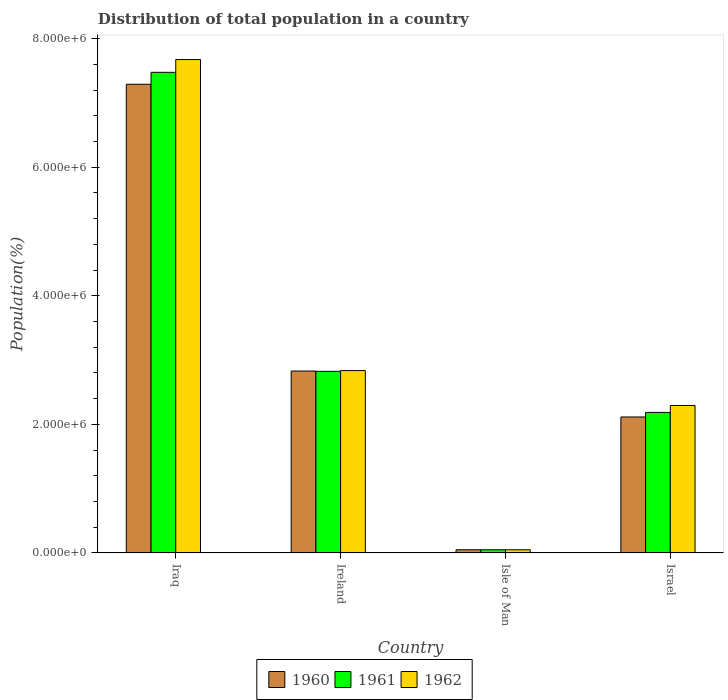How many different coloured bars are there?
Offer a very short reply. 3. How many groups of bars are there?
Make the answer very short. 4. What is the label of the 3rd group of bars from the left?
Make the answer very short. Isle of Man. What is the population of in 1961 in Isle of Man?
Provide a short and direct response. 4.84e+04. Across all countries, what is the maximum population of in 1962?
Make the answer very short. 7.67e+06. Across all countries, what is the minimum population of in 1961?
Provide a short and direct response. 4.84e+04. In which country was the population of in 1962 maximum?
Your answer should be compact. Iraq. In which country was the population of in 1962 minimum?
Your answer should be very brief. Isle of Man. What is the total population of in 1960 in the graph?
Offer a very short reply. 1.23e+07. What is the difference between the population of in 1960 in Ireland and that in Isle of Man?
Your answer should be very brief. 2.78e+06. What is the difference between the population of in 1962 in Isle of Man and the population of in 1960 in Ireland?
Your answer should be compact. -2.78e+06. What is the average population of in 1960 per country?
Make the answer very short. 3.07e+06. What is the difference between the population of of/in 1962 and population of of/in 1960 in Israel?
Your answer should be very brief. 1.79e+05. What is the ratio of the population of in 1962 in Isle of Man to that in Israel?
Your answer should be very brief. 0.02. What is the difference between the highest and the second highest population of in 1962?
Your answer should be compact. -5.43e+05. What is the difference between the highest and the lowest population of in 1961?
Ensure brevity in your answer.  7.43e+06. In how many countries, is the population of in 1960 greater than the average population of in 1960 taken over all countries?
Give a very brief answer. 1. Is the sum of the population of in 1960 in Iraq and Israel greater than the maximum population of in 1961 across all countries?
Your answer should be compact. Yes. What does the 3rd bar from the left in Israel represents?
Your response must be concise. 1962. Are all the bars in the graph horizontal?
Provide a succinct answer. No. How many countries are there in the graph?
Your response must be concise. 4. Are the values on the major ticks of Y-axis written in scientific E-notation?
Ensure brevity in your answer.  Yes. Where does the legend appear in the graph?
Make the answer very short. Bottom center. How are the legend labels stacked?
Ensure brevity in your answer.  Horizontal. What is the title of the graph?
Ensure brevity in your answer.  Distribution of total population in a country. Does "2004" appear as one of the legend labels in the graph?
Provide a succinct answer. No. What is the label or title of the X-axis?
Offer a terse response. Country. What is the label or title of the Y-axis?
Ensure brevity in your answer.  Population(%). What is the Population(%) in 1960 in Iraq?
Your response must be concise. 7.29e+06. What is the Population(%) of 1961 in Iraq?
Give a very brief answer. 7.48e+06. What is the Population(%) of 1962 in Iraq?
Your answer should be compact. 7.67e+06. What is the Population(%) of 1960 in Ireland?
Give a very brief answer. 2.83e+06. What is the Population(%) in 1961 in Ireland?
Give a very brief answer. 2.82e+06. What is the Population(%) in 1962 in Ireland?
Make the answer very short. 2.84e+06. What is the Population(%) of 1960 in Isle of Man?
Your response must be concise. 4.84e+04. What is the Population(%) in 1961 in Isle of Man?
Your answer should be compact. 4.84e+04. What is the Population(%) of 1962 in Isle of Man?
Provide a short and direct response. 4.86e+04. What is the Population(%) of 1960 in Israel?
Your response must be concise. 2.11e+06. What is the Population(%) in 1961 in Israel?
Offer a very short reply. 2.18e+06. What is the Population(%) in 1962 in Israel?
Provide a succinct answer. 2.29e+06. Across all countries, what is the maximum Population(%) of 1960?
Your answer should be very brief. 7.29e+06. Across all countries, what is the maximum Population(%) of 1961?
Offer a very short reply. 7.48e+06. Across all countries, what is the maximum Population(%) in 1962?
Your response must be concise. 7.67e+06. Across all countries, what is the minimum Population(%) in 1960?
Provide a succinct answer. 4.84e+04. Across all countries, what is the minimum Population(%) in 1961?
Your answer should be compact. 4.84e+04. Across all countries, what is the minimum Population(%) in 1962?
Make the answer very short. 4.86e+04. What is the total Population(%) in 1960 in the graph?
Offer a very short reply. 1.23e+07. What is the total Population(%) of 1961 in the graph?
Your response must be concise. 1.25e+07. What is the total Population(%) in 1962 in the graph?
Offer a terse response. 1.29e+07. What is the difference between the Population(%) in 1960 in Iraq and that in Ireland?
Make the answer very short. 4.46e+06. What is the difference between the Population(%) in 1961 in Iraq and that in Ireland?
Your answer should be very brief. 4.65e+06. What is the difference between the Population(%) in 1962 in Iraq and that in Ireland?
Ensure brevity in your answer.  4.84e+06. What is the difference between the Population(%) in 1960 in Iraq and that in Isle of Man?
Your response must be concise. 7.24e+06. What is the difference between the Population(%) of 1961 in Iraq and that in Isle of Man?
Your answer should be compact. 7.43e+06. What is the difference between the Population(%) of 1962 in Iraq and that in Isle of Man?
Offer a terse response. 7.63e+06. What is the difference between the Population(%) in 1960 in Iraq and that in Israel?
Your answer should be compact. 5.18e+06. What is the difference between the Population(%) of 1961 in Iraq and that in Israel?
Your response must be concise. 5.29e+06. What is the difference between the Population(%) of 1962 in Iraq and that in Israel?
Keep it short and to the point. 5.38e+06. What is the difference between the Population(%) of 1960 in Ireland and that in Isle of Man?
Ensure brevity in your answer.  2.78e+06. What is the difference between the Population(%) in 1961 in Ireland and that in Isle of Man?
Your response must be concise. 2.78e+06. What is the difference between the Population(%) in 1962 in Ireland and that in Isle of Man?
Provide a succinct answer. 2.79e+06. What is the difference between the Population(%) of 1960 in Ireland and that in Israel?
Offer a very short reply. 7.15e+05. What is the difference between the Population(%) of 1961 in Ireland and that in Israel?
Ensure brevity in your answer.  6.39e+05. What is the difference between the Population(%) of 1962 in Ireland and that in Israel?
Make the answer very short. 5.43e+05. What is the difference between the Population(%) in 1960 in Isle of Man and that in Israel?
Your answer should be very brief. -2.07e+06. What is the difference between the Population(%) in 1961 in Isle of Man and that in Israel?
Your response must be concise. -2.14e+06. What is the difference between the Population(%) in 1962 in Isle of Man and that in Israel?
Provide a succinct answer. -2.24e+06. What is the difference between the Population(%) of 1960 in Iraq and the Population(%) of 1961 in Ireland?
Provide a short and direct response. 4.47e+06. What is the difference between the Population(%) of 1960 in Iraq and the Population(%) of 1962 in Ireland?
Make the answer very short. 4.45e+06. What is the difference between the Population(%) of 1961 in Iraq and the Population(%) of 1962 in Ireland?
Keep it short and to the point. 4.64e+06. What is the difference between the Population(%) in 1960 in Iraq and the Population(%) in 1961 in Isle of Man?
Provide a short and direct response. 7.24e+06. What is the difference between the Population(%) of 1960 in Iraq and the Population(%) of 1962 in Isle of Man?
Keep it short and to the point. 7.24e+06. What is the difference between the Population(%) in 1961 in Iraq and the Population(%) in 1962 in Isle of Man?
Provide a short and direct response. 7.43e+06. What is the difference between the Population(%) in 1960 in Iraq and the Population(%) in 1961 in Israel?
Your answer should be compact. 5.10e+06. What is the difference between the Population(%) of 1960 in Iraq and the Population(%) of 1962 in Israel?
Your answer should be very brief. 5.00e+06. What is the difference between the Population(%) in 1961 in Iraq and the Population(%) in 1962 in Israel?
Keep it short and to the point. 5.18e+06. What is the difference between the Population(%) of 1960 in Ireland and the Population(%) of 1961 in Isle of Man?
Keep it short and to the point. 2.78e+06. What is the difference between the Population(%) of 1960 in Ireland and the Population(%) of 1962 in Isle of Man?
Offer a terse response. 2.78e+06. What is the difference between the Population(%) in 1961 in Ireland and the Population(%) in 1962 in Isle of Man?
Your answer should be compact. 2.78e+06. What is the difference between the Population(%) of 1960 in Ireland and the Population(%) of 1961 in Israel?
Offer a terse response. 6.44e+05. What is the difference between the Population(%) of 1960 in Ireland and the Population(%) of 1962 in Israel?
Your response must be concise. 5.36e+05. What is the difference between the Population(%) in 1961 in Ireland and the Population(%) in 1962 in Israel?
Offer a very short reply. 5.31e+05. What is the difference between the Population(%) in 1960 in Isle of Man and the Population(%) in 1961 in Israel?
Give a very brief answer. -2.14e+06. What is the difference between the Population(%) of 1960 in Isle of Man and the Population(%) of 1962 in Israel?
Ensure brevity in your answer.  -2.24e+06. What is the difference between the Population(%) of 1961 in Isle of Man and the Population(%) of 1962 in Israel?
Give a very brief answer. -2.24e+06. What is the average Population(%) in 1960 per country?
Ensure brevity in your answer.  3.07e+06. What is the average Population(%) of 1961 per country?
Your answer should be compact. 3.13e+06. What is the average Population(%) of 1962 per country?
Your answer should be very brief. 3.21e+06. What is the difference between the Population(%) of 1960 and Population(%) of 1961 in Iraq?
Give a very brief answer. -1.86e+05. What is the difference between the Population(%) in 1960 and Population(%) in 1962 in Iraq?
Offer a terse response. -3.84e+05. What is the difference between the Population(%) in 1961 and Population(%) in 1962 in Iraq?
Your response must be concise. -1.99e+05. What is the difference between the Population(%) of 1960 and Population(%) of 1961 in Ireland?
Provide a succinct answer. 4200. What is the difference between the Population(%) in 1960 and Population(%) in 1962 in Ireland?
Provide a succinct answer. -7450. What is the difference between the Population(%) of 1961 and Population(%) of 1962 in Ireland?
Ensure brevity in your answer.  -1.16e+04. What is the difference between the Population(%) in 1960 and Population(%) in 1962 in Isle of Man?
Give a very brief answer. -139. What is the difference between the Population(%) of 1961 and Population(%) of 1962 in Isle of Man?
Your response must be concise. -227. What is the difference between the Population(%) in 1960 and Population(%) in 1961 in Israel?
Make the answer very short. -7.10e+04. What is the difference between the Population(%) of 1960 and Population(%) of 1962 in Israel?
Your response must be concise. -1.79e+05. What is the difference between the Population(%) of 1961 and Population(%) of 1962 in Israel?
Ensure brevity in your answer.  -1.08e+05. What is the ratio of the Population(%) of 1960 in Iraq to that in Ireland?
Provide a succinct answer. 2.58. What is the ratio of the Population(%) in 1961 in Iraq to that in Ireland?
Provide a short and direct response. 2.65. What is the ratio of the Population(%) of 1962 in Iraq to that in Ireland?
Give a very brief answer. 2.71. What is the ratio of the Population(%) in 1960 in Iraq to that in Isle of Man?
Offer a terse response. 150.49. What is the ratio of the Population(%) of 1961 in Iraq to that in Isle of Man?
Provide a succinct answer. 154.6. What is the ratio of the Population(%) in 1962 in Iraq to that in Isle of Man?
Offer a very short reply. 157.97. What is the ratio of the Population(%) in 1960 in Iraq to that in Israel?
Make the answer very short. 3.45. What is the ratio of the Population(%) of 1961 in Iraq to that in Israel?
Ensure brevity in your answer.  3.42. What is the ratio of the Population(%) in 1962 in Iraq to that in Israel?
Offer a very short reply. 3.35. What is the ratio of the Population(%) in 1960 in Ireland to that in Isle of Man?
Your response must be concise. 58.39. What is the ratio of the Population(%) in 1961 in Ireland to that in Isle of Man?
Ensure brevity in your answer.  58.41. What is the ratio of the Population(%) of 1962 in Ireland to that in Isle of Man?
Keep it short and to the point. 58.38. What is the ratio of the Population(%) of 1960 in Ireland to that in Israel?
Keep it short and to the point. 1.34. What is the ratio of the Population(%) in 1961 in Ireland to that in Israel?
Provide a short and direct response. 1.29. What is the ratio of the Population(%) in 1962 in Ireland to that in Israel?
Offer a terse response. 1.24. What is the ratio of the Population(%) of 1960 in Isle of Man to that in Israel?
Your response must be concise. 0.02. What is the ratio of the Population(%) of 1961 in Isle of Man to that in Israel?
Offer a terse response. 0.02. What is the ratio of the Population(%) of 1962 in Isle of Man to that in Israel?
Your answer should be compact. 0.02. What is the difference between the highest and the second highest Population(%) in 1960?
Make the answer very short. 4.46e+06. What is the difference between the highest and the second highest Population(%) of 1961?
Your answer should be compact. 4.65e+06. What is the difference between the highest and the second highest Population(%) of 1962?
Offer a very short reply. 4.84e+06. What is the difference between the highest and the lowest Population(%) of 1960?
Keep it short and to the point. 7.24e+06. What is the difference between the highest and the lowest Population(%) of 1961?
Give a very brief answer. 7.43e+06. What is the difference between the highest and the lowest Population(%) in 1962?
Keep it short and to the point. 7.63e+06. 